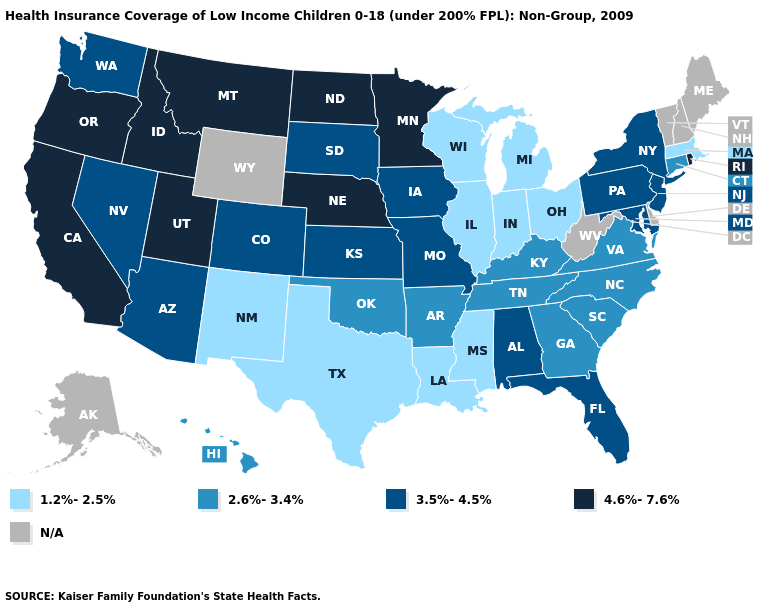Which states have the highest value in the USA?
Write a very short answer. California, Idaho, Minnesota, Montana, Nebraska, North Dakota, Oregon, Rhode Island, Utah. Which states have the highest value in the USA?
Short answer required. California, Idaho, Minnesota, Montana, Nebraska, North Dakota, Oregon, Rhode Island, Utah. Which states have the lowest value in the West?
Answer briefly. New Mexico. Which states have the lowest value in the USA?
Concise answer only. Illinois, Indiana, Louisiana, Massachusetts, Michigan, Mississippi, New Mexico, Ohio, Texas, Wisconsin. Among the states that border Connecticut , does Massachusetts have the highest value?
Give a very brief answer. No. What is the value of California?
Quick response, please. 4.6%-7.6%. Among the states that border Pennsylvania , does Maryland have the highest value?
Give a very brief answer. Yes. What is the highest value in the USA?
Be succinct. 4.6%-7.6%. Which states have the lowest value in the USA?
Give a very brief answer. Illinois, Indiana, Louisiana, Massachusetts, Michigan, Mississippi, New Mexico, Ohio, Texas, Wisconsin. Name the states that have a value in the range 3.5%-4.5%?
Answer briefly. Alabama, Arizona, Colorado, Florida, Iowa, Kansas, Maryland, Missouri, Nevada, New Jersey, New York, Pennsylvania, South Dakota, Washington. Does California have the highest value in the USA?
Quick response, please. Yes. Is the legend a continuous bar?
Quick response, please. No. Which states have the lowest value in the West?
Concise answer only. New Mexico. 